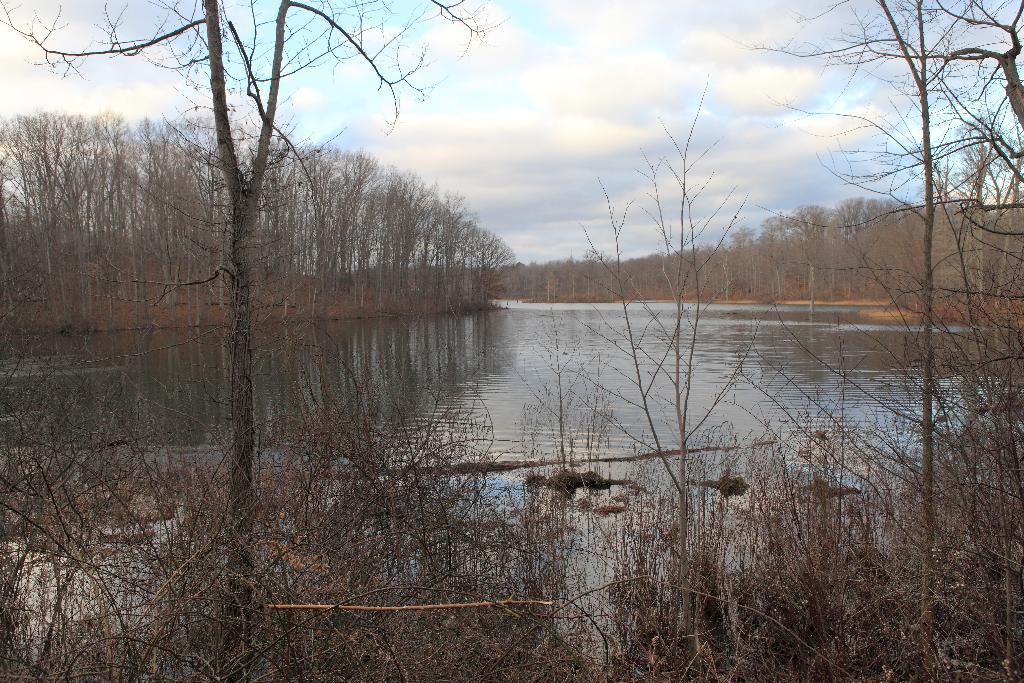What type of living organisms can be seen in the image? Plants and a tree are visible in the image. What natural element is present in the image? Water is visible in the image. What can be seen in the background of the image? Trees and the sky are visible in the background of the image. What type of hammer is being used by the children in the image? There are no children or hammers present in the image. 